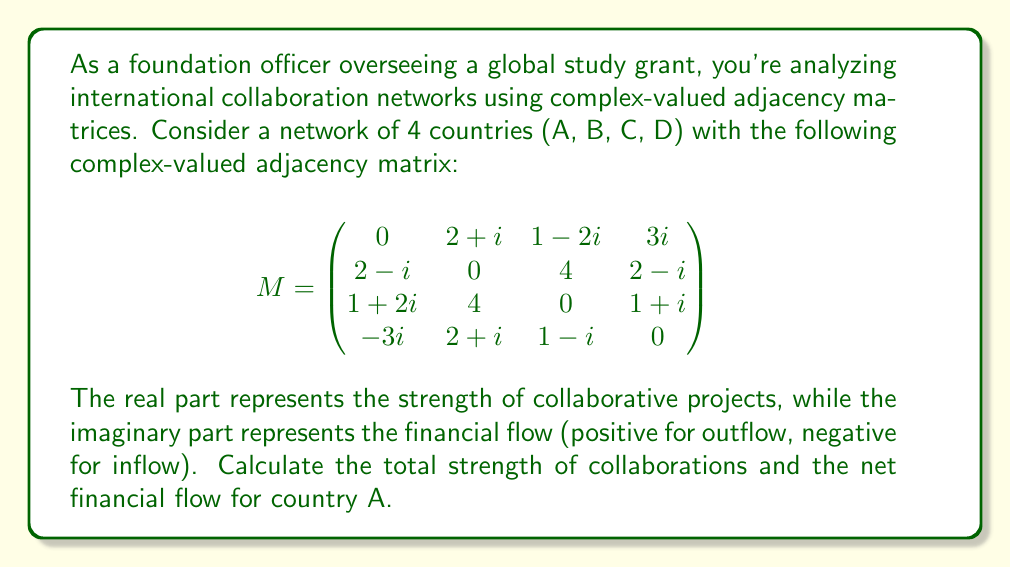Help me with this question. To solve this problem, we need to analyze the first row of the adjacency matrix, which represents country A's connections:

1) The elements in the first row are:
   $M_{1,2} = 2+i$, $M_{1,3} = 1-2i$, $M_{1,4} = 3i$

2) To calculate the total strength of collaborations:
   - Sum the real parts of these elements
   - $(2+i) + (1-2i) + 3i = (2+1) + (i-2i+3i) = 3+2i$
   - The real part is 3

3) To calculate the net financial flow:
   - Sum the imaginary parts of these elements
   - The imaginary part of the sum is $2i$
   - A positive imaginary part indicates a net outflow

4) Therefore:
   - Total strength of collaborations = 3
   - Net financial flow = 2 (outflow)
Answer: 3, 2 (outflow) 